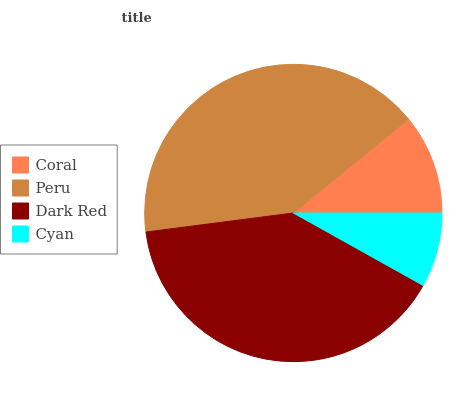Is Cyan the minimum?
Answer yes or no. Yes. Is Peru the maximum?
Answer yes or no. Yes. Is Dark Red the minimum?
Answer yes or no. No. Is Dark Red the maximum?
Answer yes or no. No. Is Peru greater than Dark Red?
Answer yes or no. Yes. Is Dark Red less than Peru?
Answer yes or no. Yes. Is Dark Red greater than Peru?
Answer yes or no. No. Is Peru less than Dark Red?
Answer yes or no. No. Is Dark Red the high median?
Answer yes or no. Yes. Is Coral the low median?
Answer yes or no. Yes. Is Peru the high median?
Answer yes or no. No. Is Peru the low median?
Answer yes or no. No. 